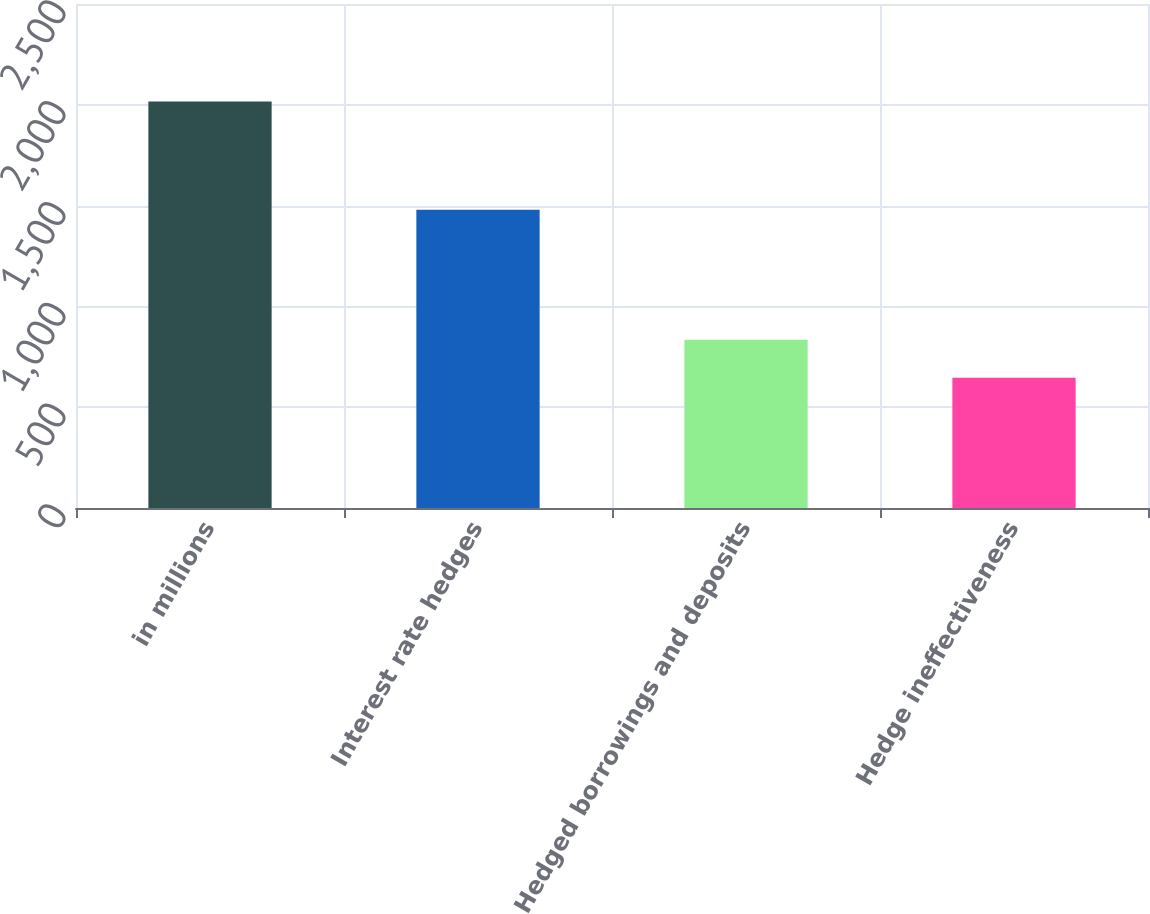<chart> <loc_0><loc_0><loc_500><loc_500><bar_chart><fcel>in millions<fcel>Interest rate hedges<fcel>Hedged borrowings and deposits<fcel>Hedge ineffectiveness<nl><fcel>2016<fcel>1480<fcel>834<fcel>646<nl></chart> 